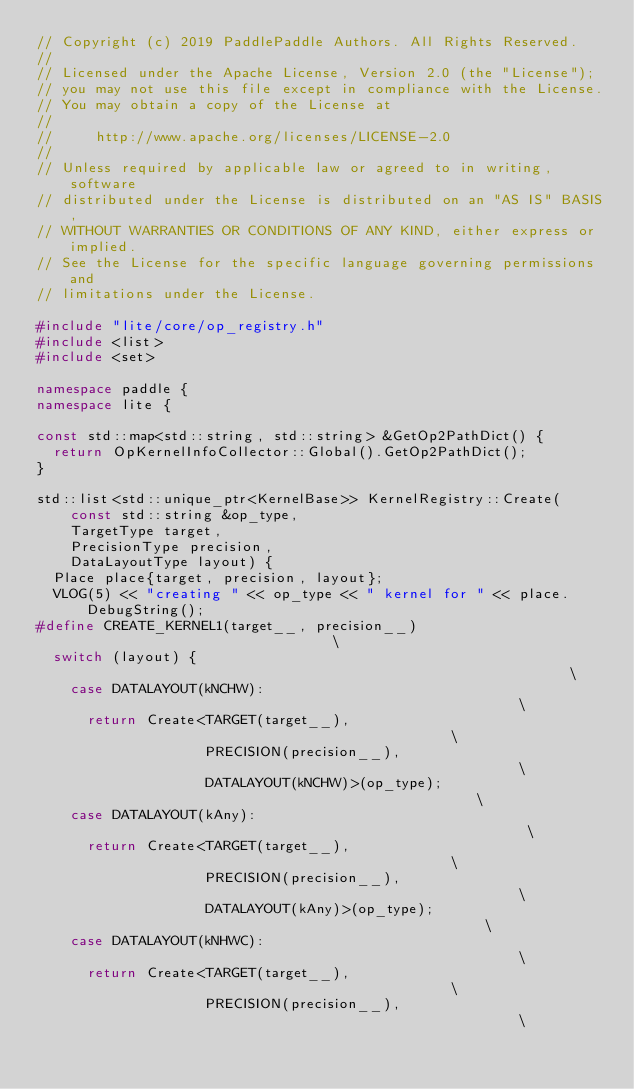Convert code to text. <code><loc_0><loc_0><loc_500><loc_500><_C++_>// Copyright (c) 2019 PaddlePaddle Authors. All Rights Reserved.
//
// Licensed under the Apache License, Version 2.0 (the "License");
// you may not use this file except in compliance with the License.
// You may obtain a copy of the License at
//
//     http://www.apache.org/licenses/LICENSE-2.0
//
// Unless required by applicable law or agreed to in writing, software
// distributed under the License is distributed on an "AS IS" BASIS,
// WITHOUT WARRANTIES OR CONDITIONS OF ANY KIND, either express or implied.
// See the License for the specific language governing permissions and
// limitations under the License.

#include "lite/core/op_registry.h"
#include <list>
#include <set>

namespace paddle {
namespace lite {

const std::map<std::string, std::string> &GetOp2PathDict() {
  return OpKernelInfoCollector::Global().GetOp2PathDict();
}

std::list<std::unique_ptr<KernelBase>> KernelRegistry::Create(
    const std::string &op_type,
    TargetType target,
    PrecisionType precision,
    DataLayoutType layout) {
  Place place{target, precision, layout};
  VLOG(5) << "creating " << op_type << " kernel for " << place.DebugString();
#define CREATE_KERNEL1(target__, precision__)                                \
  switch (layout) {                                                          \
    case DATALAYOUT(kNCHW):                                                  \
      return Create<TARGET(target__),                                        \
                    PRECISION(precision__),                                  \
                    DATALAYOUT(kNCHW)>(op_type);                             \
    case DATALAYOUT(kAny):                                                   \
      return Create<TARGET(target__),                                        \
                    PRECISION(precision__),                                  \
                    DATALAYOUT(kAny)>(op_type);                              \
    case DATALAYOUT(kNHWC):                                                  \
      return Create<TARGET(target__),                                        \
                    PRECISION(precision__),                                  \</code> 